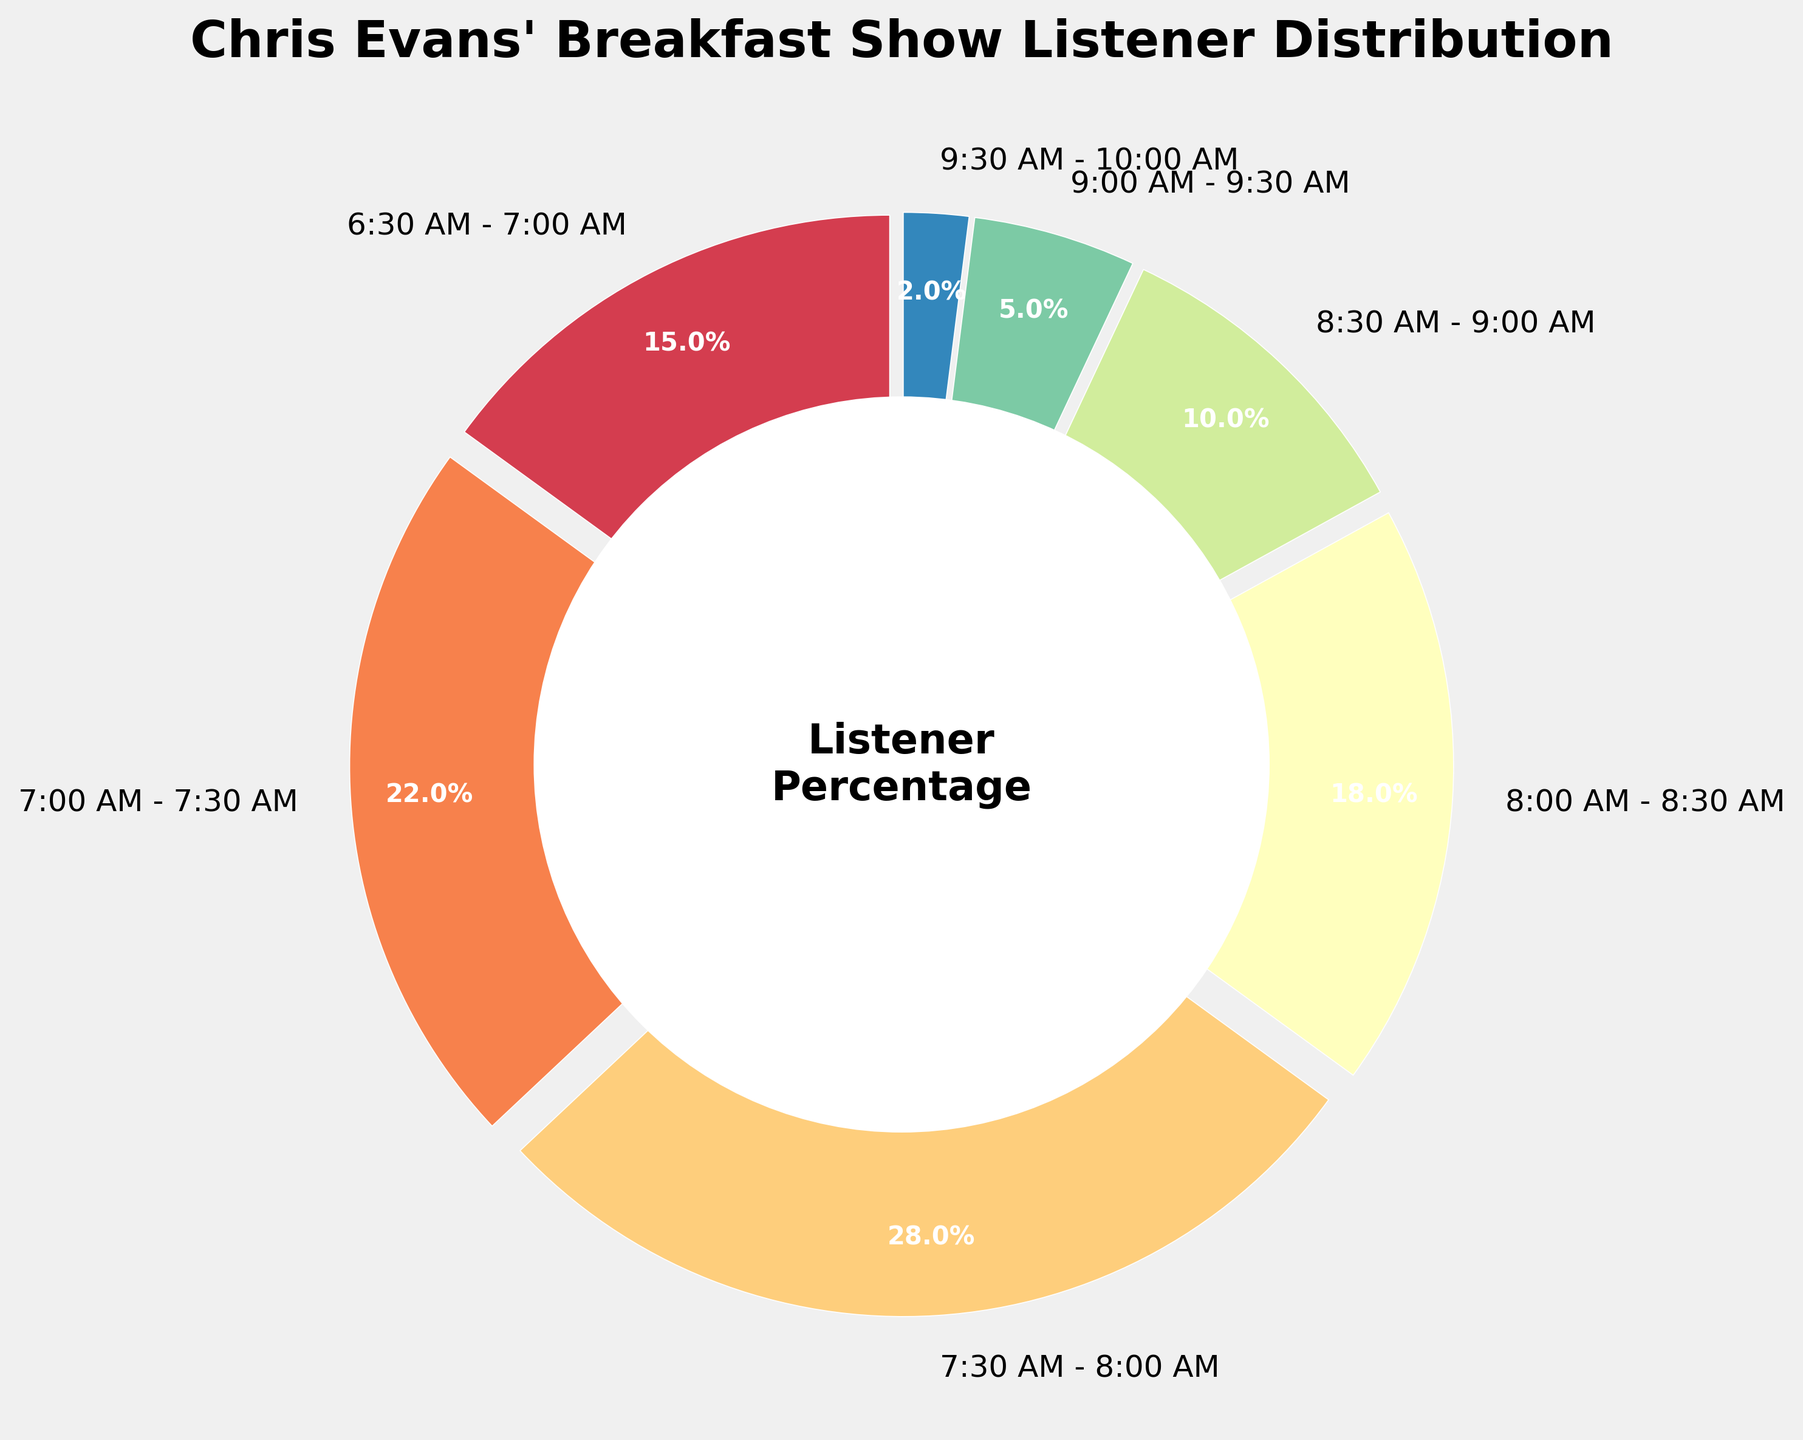What is the time slot with the highest percentage of listeners? Look at the sectors of the pie chart. The largest sector corresponds to the time slot 7:30 AM - 8:00 AM with 28%.
Answer: 7:30 AM - 8:00 AM Which time slot has the lowest listener percentage? The smallest sector in the pie chart represents the time slot from 9:30 AM to 10:00 AM with 2%.
Answer: 9:30 AM - 10:00 AM What is the combined percentage of listeners from 6:30 AM to 7:00 AM and 7:00 AM to 7:30 AM? Add the percentages of the time slots 6:30 AM - 7:00 AM (15%) and 7:00 AM - 7:30 AM (22%). The sum is 15% + 22% = 37%.
Answer: 37% How much greater is the listener percentage in the 8:00 AM - 8:30 AM slot compared to the 9:00 AM - 9:30 AM slot? Subtract the percentage of the 9:00 AM - 9:30 AM slot (5%) from the 8:00 AM - 8:30 AM slot (18%). The difference is 18% - 5% = 13%.
Answer: 13% What percentage of listeners tune in after 9:00 AM? Sum the percentages of the time slots after 9:00 AM: 9:00 AM - 9:30 AM (5%) and 9:30 AM - 10:00 AM (2%). The total is 5% + 2% = 7%.
Answer: 7% Is the percentage of listeners from 7:30 AM to 8:00 AM more than double that of 9:00 AM to 9:30 AM? Compare 28% (7:30 AM - 8:00 AM) with double the 5% (9:00 AM - 9:30 AM). 28% is indeed greater than 10% (double of 5%).
Answer: Yes Which periods together acquire more than 50% of the total listener percentage? Add up the percentages starting from the highest until the total surpasses 50%. The periods 7:30 AM - 8:00 AM (28%) and 7:00 AM - 7:30 AM (22%) sum to 50%, and just these periods make up 50%. Thus, adding any one period beyond this will exceed 50%.
Answer: 7:30 AM - 8:00 AM and 7:00 AM - 7:30 AM 